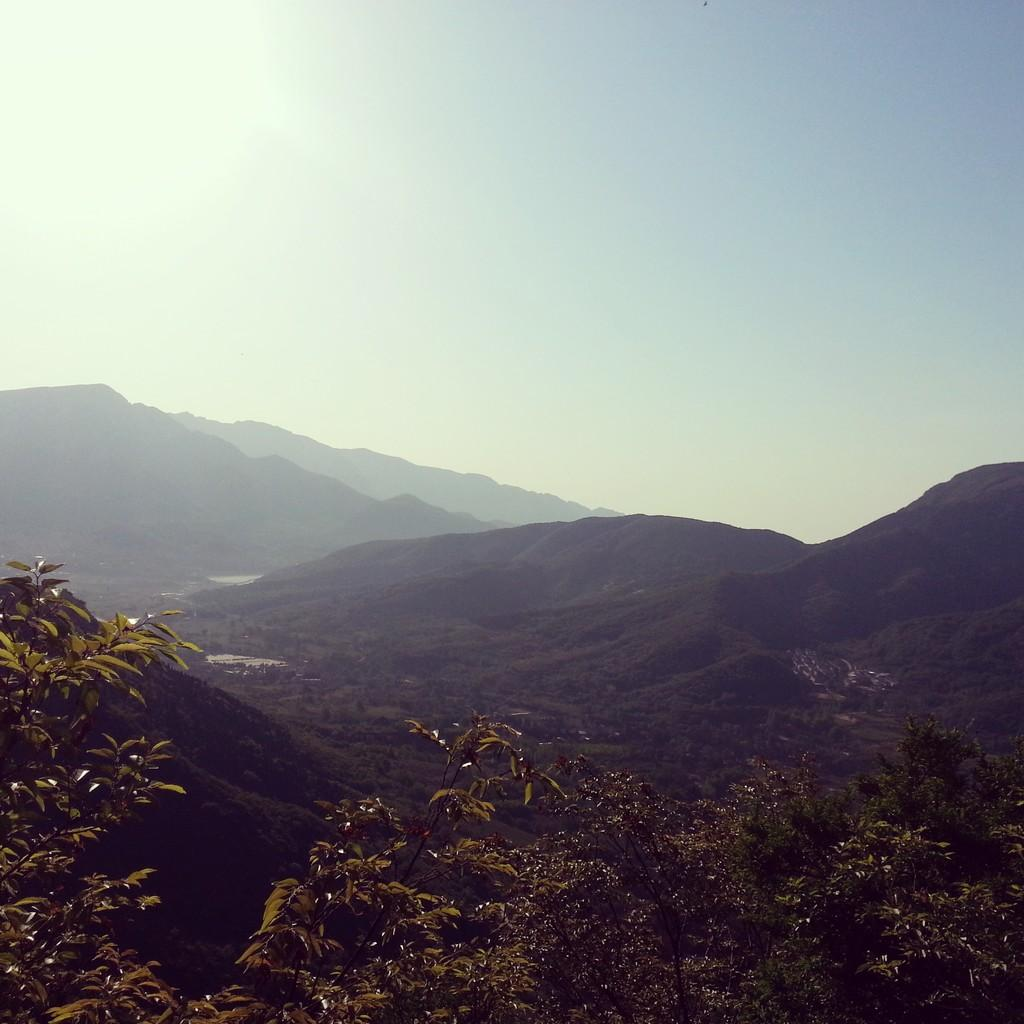What type of vegetation is in the front of the image? There are trees in the front of the image. What can be seen in the background of the image? There are hills visible in the background of the image. What is visible at the top of the image? The sky is visible at the top of the image. What type of plot is being used to grow the trees in the image? There is no information about the type of plot or method of cultivation for the trees in the image. What ingredients are used to make the stew visible in the image? There is no stew present in the image. 